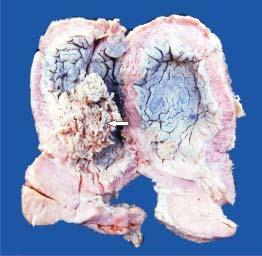does the mucosal surface show papillary tumour floating in the lumen?
Answer the question using a single word or phrase. Yes 